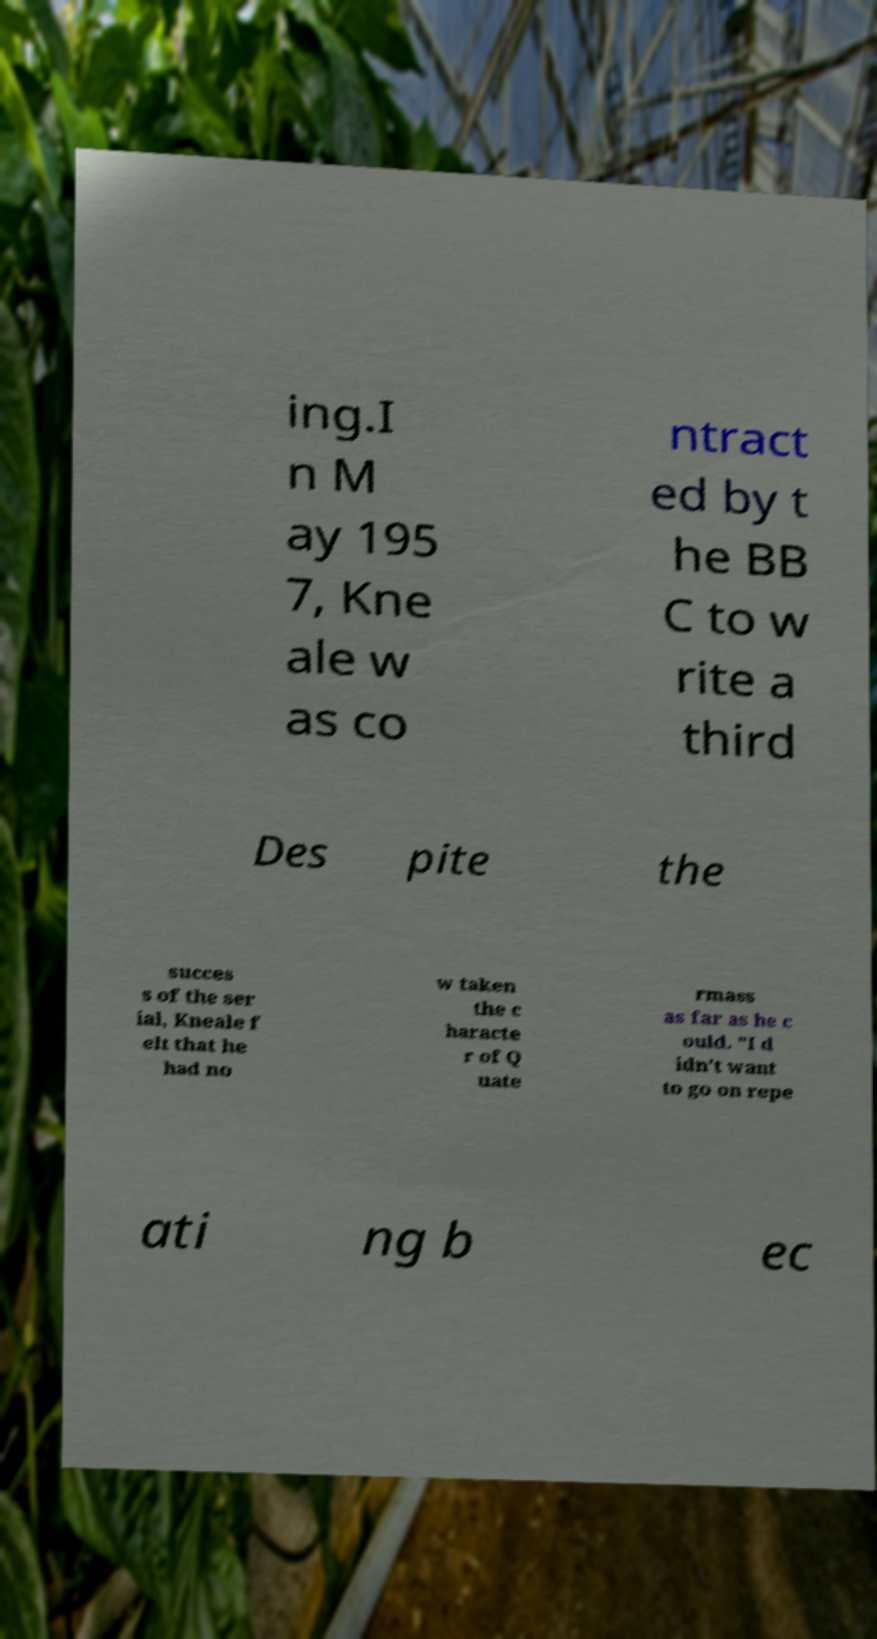Can you read and provide the text displayed in the image?This photo seems to have some interesting text. Can you extract and type it out for me? ing.I n M ay 195 7, Kne ale w as co ntract ed by t he BB C to w rite a third Des pite the succes s of the ser ial, Kneale f elt that he had no w taken the c haracte r of Q uate rmass as far as he c ould. "I d idn't want to go on repe ati ng b ec 